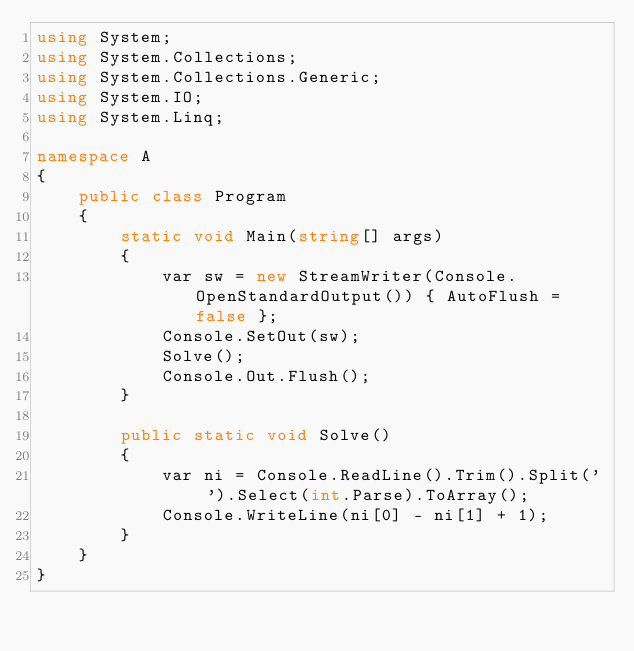<code> <loc_0><loc_0><loc_500><loc_500><_C#_>using System;
using System.Collections;
using System.Collections.Generic;
using System.IO;
using System.Linq;

namespace A
{
    public class Program
    {
        static void Main(string[] args)
        {
            var sw = new StreamWriter(Console.OpenStandardOutput()) { AutoFlush = false };
            Console.SetOut(sw);
            Solve();
            Console.Out.Flush();
        }

        public static void Solve()
        {
            var ni = Console.ReadLine().Trim().Split(' ').Select(int.Parse).ToArray();
            Console.WriteLine(ni[0] - ni[1] + 1);
        }
    }
}
</code> 